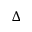<formula> <loc_0><loc_0><loc_500><loc_500>\Delta</formula> 